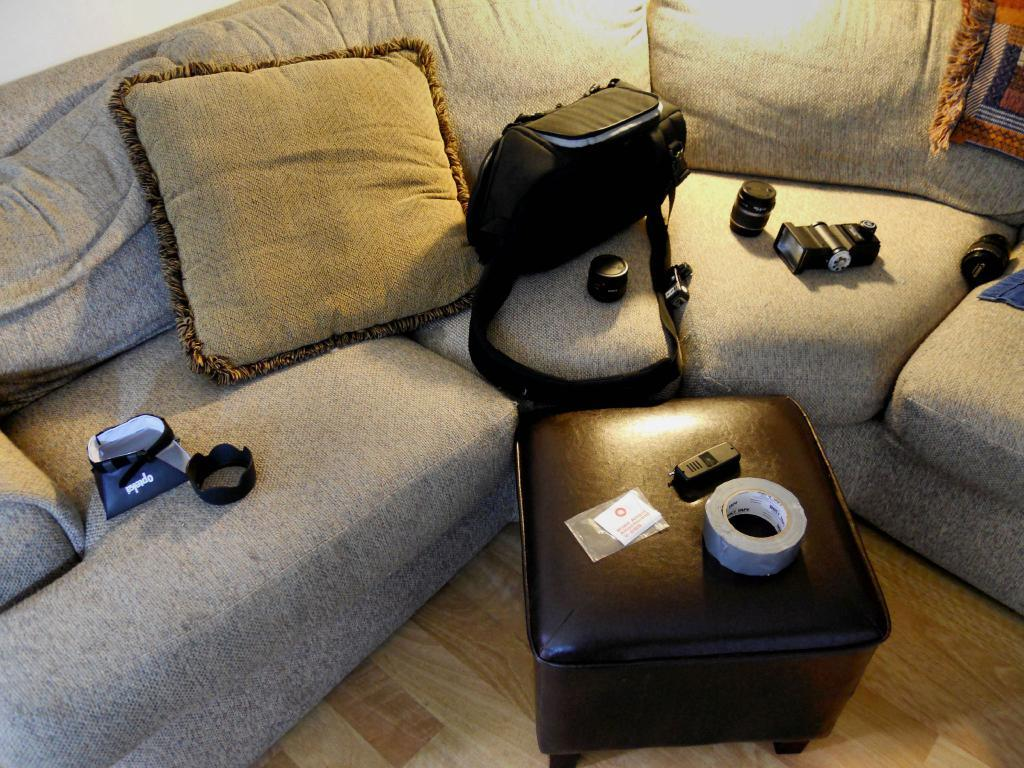What type of furniture is present in the image? There is a sofa and a table on the floor in the image. What items can be seen on the floor? There are bags and a plaster roll on the floor in the image. What is placed on the sofa? There is a pillow on the sofa in the image. What material is visible in the image? There is cloth in the image. What device is used to capture images in the scene? There is a camera in the image. Are there any other objects present in the image? Yes, there are additional objects in the image. How many chairs are visible in the image? There are no chairs visible in the image. What type of fruit is being used as a decoration on the table? There is no fruit, specifically a pear, present in the image. 